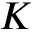<formula> <loc_0><loc_0><loc_500><loc_500>K</formula> 